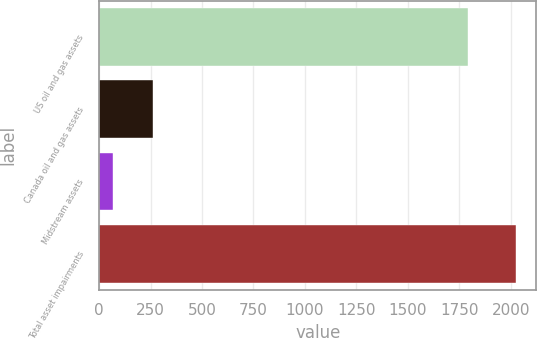Convert chart. <chart><loc_0><loc_0><loc_500><loc_500><bar_chart><fcel>US oil and gas assets<fcel>Canada oil and gas assets<fcel>Midstream assets<fcel>Total asset impairments<nl><fcel>1793<fcel>263.6<fcel>68<fcel>2024<nl></chart> 